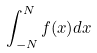<formula> <loc_0><loc_0><loc_500><loc_500>\int _ { - N } ^ { N } f ( x ) d x</formula> 